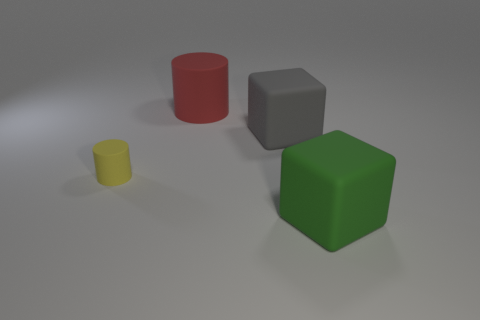What material is the green block?
Provide a short and direct response. Rubber. The large green matte object is what shape?
Offer a very short reply. Cube. What material is the object to the left of the cylinder behind the large rubber cube to the left of the green thing made of?
Make the answer very short. Rubber. What number of blue things are rubber cylinders or large rubber cylinders?
Offer a terse response. 0. What is the size of the matte cylinder in front of the matte thing that is behind the block that is behind the big green block?
Give a very brief answer. Small. There is a green object that is the same shape as the big gray object; what is its size?
Ensure brevity in your answer.  Large. How many large objects are purple matte objects or red objects?
Your answer should be compact. 1. Do the green cube that is right of the tiny yellow rubber cylinder and the thing that is left of the big rubber cylinder have the same material?
Provide a succinct answer. Yes. There is a cylinder behind the small cylinder; what material is it?
Provide a short and direct response. Rubber. How many metallic things are either large green blocks or small cyan balls?
Your answer should be very brief. 0. 